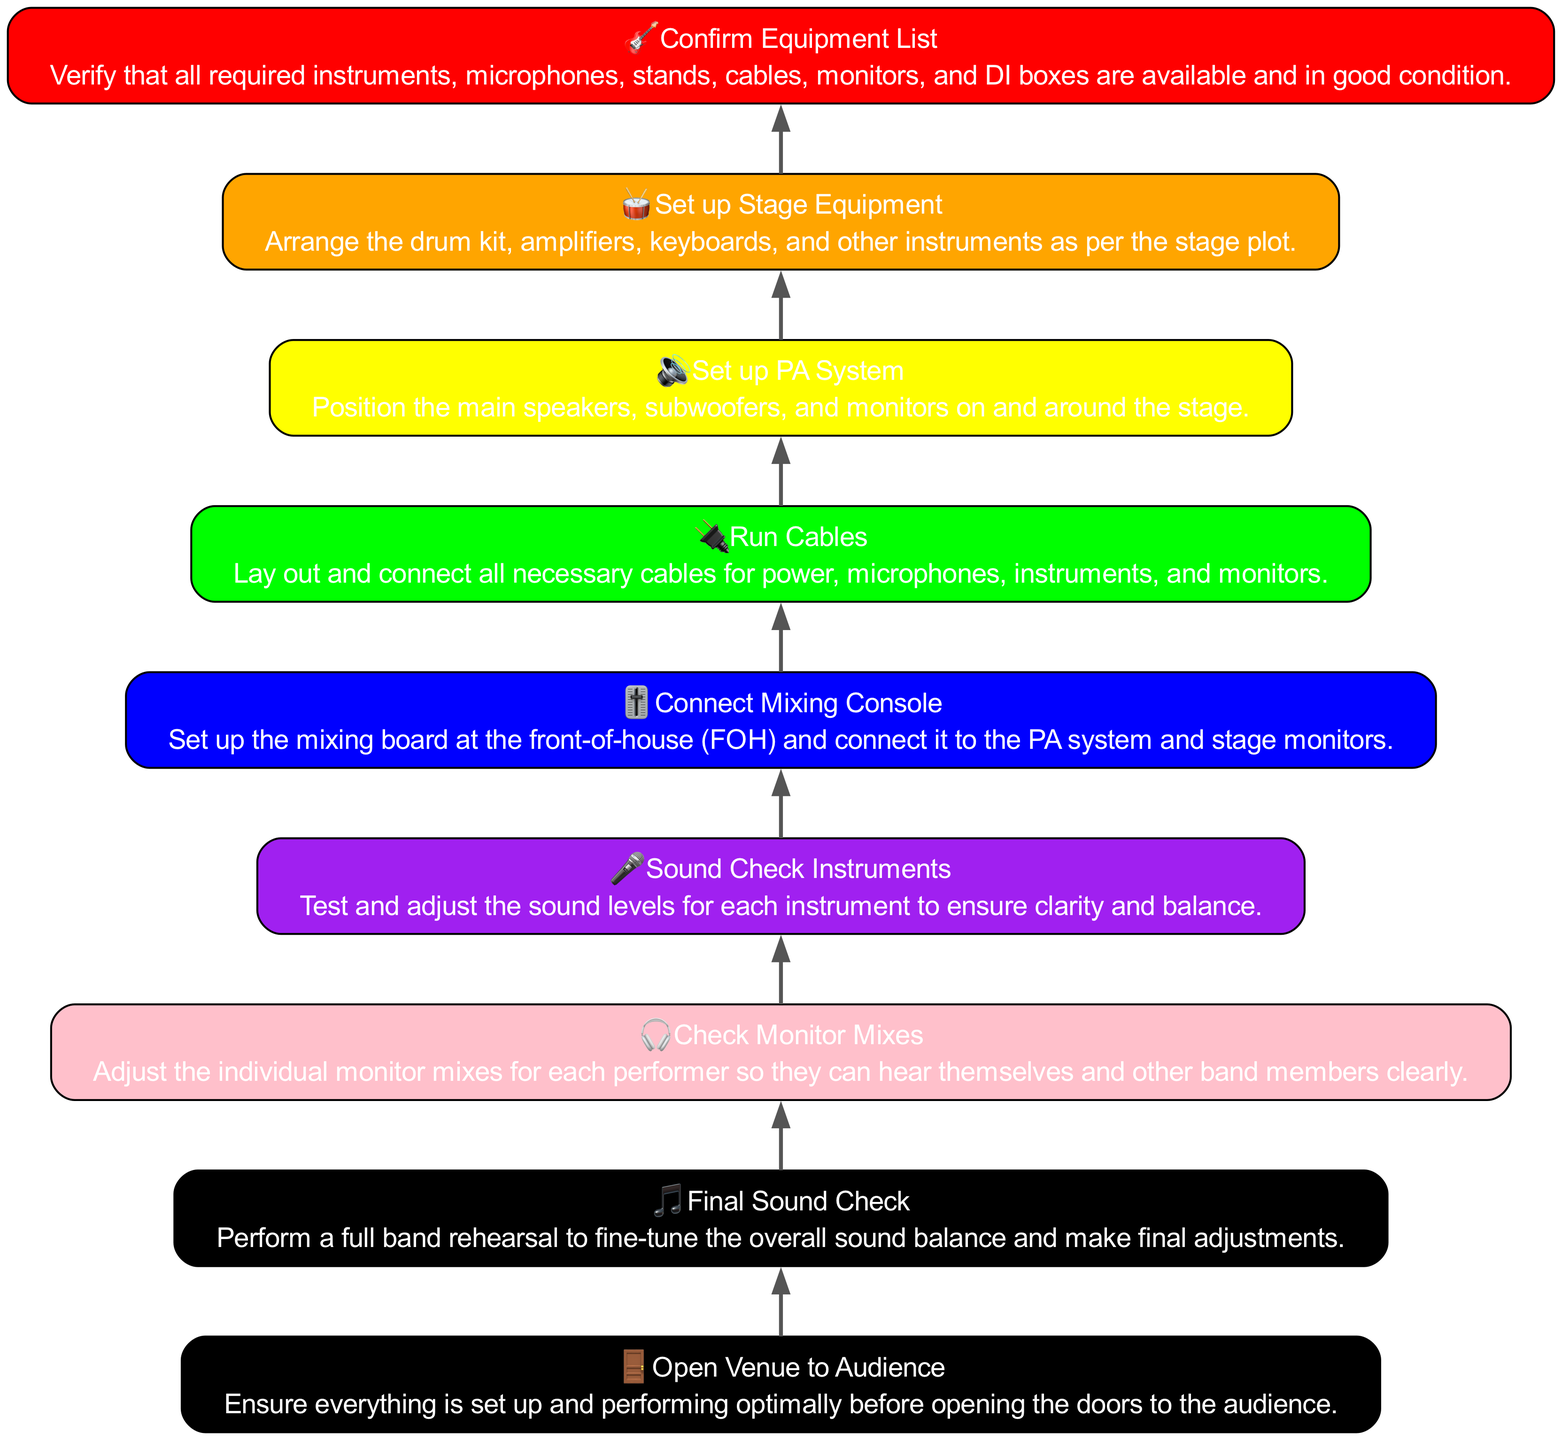What is the first step in the flow chart? The first step in the flow chart is at the bottom and is labeled "Confirm Equipment List," which indicates that the verification of all required materials occurs at the beginning of the setup process.
Answer: Confirm Equipment List How many nodes are there in the diagram? The diagram consists of 8 nodes, each representing a step in the process, starting from "Confirm Equipment List" at the bottom to "Open Venue to Audience" at the top.
Answer: 8 What is the color of the "Connect Mixing Console" step? The "Connect Mixing Console" step is colored blue, as indicated in the details of the node that represents this part of the flow chart.
Answer: Blue Which step is directly above "Sound Check Instruments"? Directly above "Sound Check Instruments" is the "Check Monitor Mixes" step, indicating that the check for individual monitor mixes occurs after testing the sound levels for instruments.
Answer: Check Monitor Mixes What is the last step before opening the venue? The last step before opening the venue is "Final Sound Check," where a full band rehearsal is performed to finalize adjustments before the audience arrives.
Answer: Final Sound Check What are the last three steps in the setup process? The last three steps, starting from the bottom up, are "Sound Check Instruments," "Check Monitor Mixes," and "Final Sound Check," showing the sequence of audio adjustments and checks before the venue opening.
Answer: Sound Check Instruments, Check Monitor Mixes, Final Sound Check Which step involves laying out and connecting all necessary cables? The step that involves laying out and connecting all necessary cables is called "Run Cables," and it is essential for integrating all audio equipment.
Answer: Run Cables How many steps are there between "Set up Stage Equipment" and "Open Venue to Audience"? There are four steps between "Set up Stage Equipment" and "Open Venue to Audience," which are "Set up PA System," "Run Cables," "Connect Mixing Console," and "Sound Check Instruments."
Answer: 4 What is the icon representing the "Final Sound Check"? The icon representing the "Final Sound Check" is a musical note, symbolizing the completion and refinement of the sound setup for the concert.
Answer: 🎵 